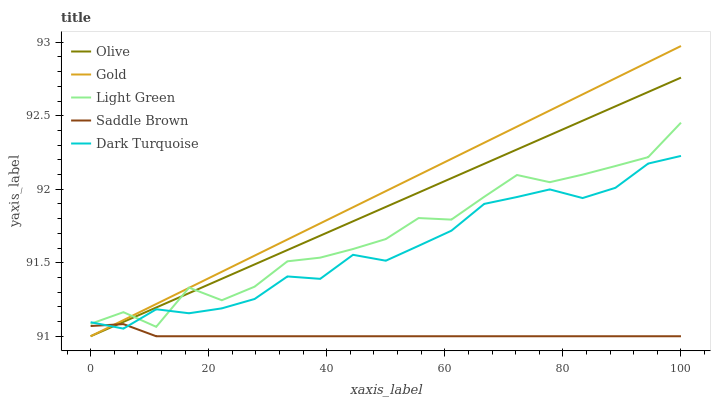Does Saddle Brown have the minimum area under the curve?
Answer yes or no. Yes. Does Gold have the maximum area under the curve?
Answer yes or no. Yes. Does Dark Turquoise have the minimum area under the curve?
Answer yes or no. No. Does Dark Turquoise have the maximum area under the curve?
Answer yes or no. No. Is Olive the smoothest?
Answer yes or no. Yes. Is Light Green the roughest?
Answer yes or no. Yes. Is Dark Turquoise the smoothest?
Answer yes or no. No. Is Dark Turquoise the roughest?
Answer yes or no. No. Does Olive have the lowest value?
Answer yes or no. Yes. Does Dark Turquoise have the lowest value?
Answer yes or no. No. Does Gold have the highest value?
Answer yes or no. Yes. Does Dark Turquoise have the highest value?
Answer yes or no. No. Is Saddle Brown less than Light Green?
Answer yes or no. Yes. Is Light Green greater than Saddle Brown?
Answer yes or no. Yes. Does Gold intersect Saddle Brown?
Answer yes or no. Yes. Is Gold less than Saddle Brown?
Answer yes or no. No. Is Gold greater than Saddle Brown?
Answer yes or no. No. Does Saddle Brown intersect Light Green?
Answer yes or no. No. 